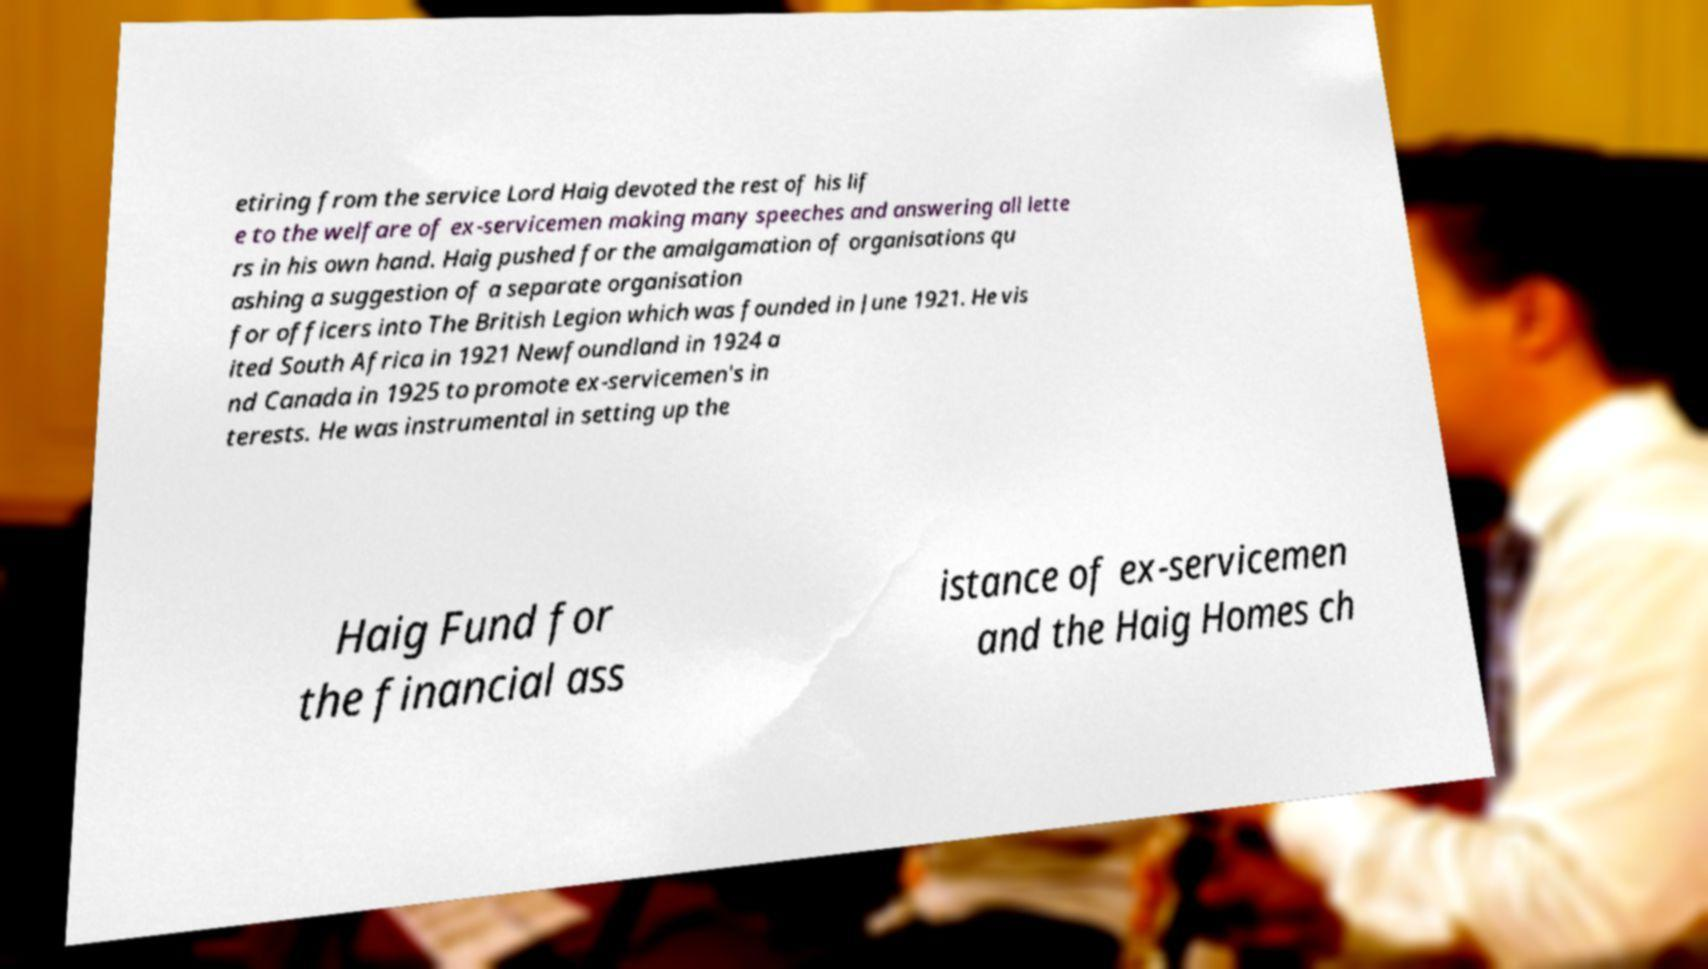Please identify and transcribe the text found in this image. etiring from the service Lord Haig devoted the rest of his lif e to the welfare of ex-servicemen making many speeches and answering all lette rs in his own hand. Haig pushed for the amalgamation of organisations qu ashing a suggestion of a separate organisation for officers into The British Legion which was founded in June 1921. He vis ited South Africa in 1921 Newfoundland in 1924 a nd Canada in 1925 to promote ex-servicemen's in terests. He was instrumental in setting up the Haig Fund for the financial ass istance of ex-servicemen and the Haig Homes ch 